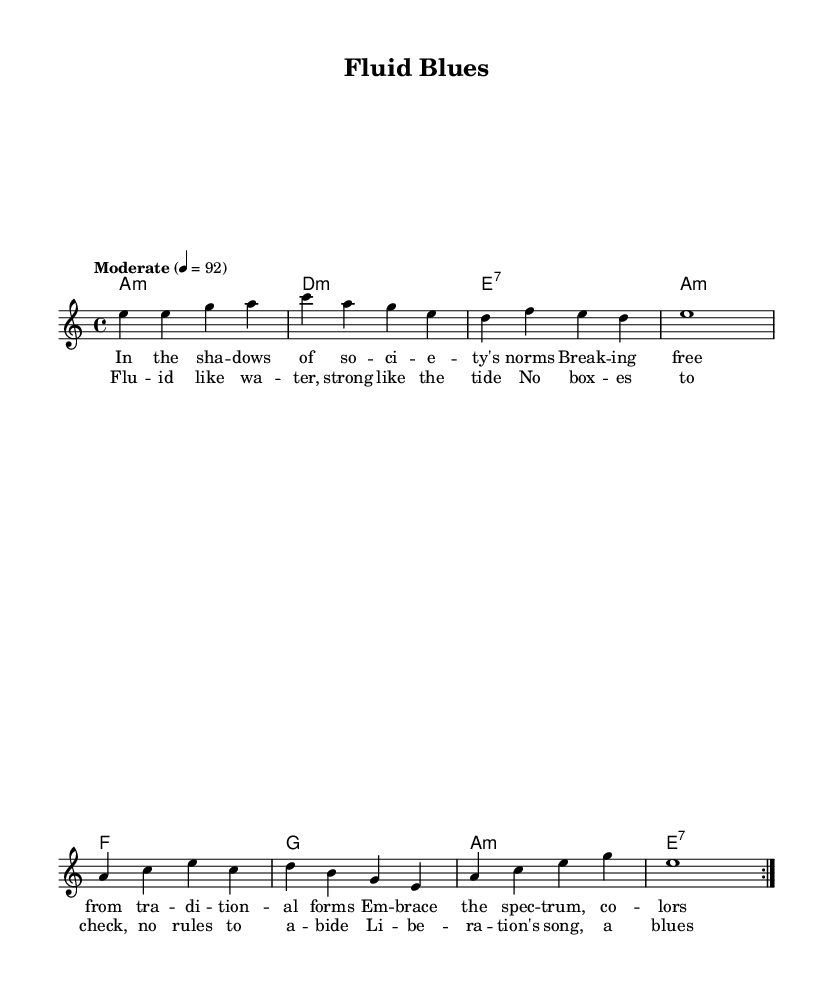What is the key signature of this music? The key signature is identified by the absence of sharps or flats in the title and throughout the piece, which indicates that it is in A minor.
Answer: A minor What is the time signature of this music? The time signature is shown at the beginning of the piece, indicated by the "4/4" notation, meaning there are four beats in each measure.
Answer: 4/4 What is the tempo marking for this piece? The tempo is indicated by the text "Moderate" followed by the metronome marking of 4 equals 92, which tells the performer how fast to play the music.
Answer: Moderate How many measures are in the repeated section of the melody? By analyzing the structure shown in the repeated section, there are two measures that consist of both the melody and the corresponding harmonies. Each section is marked with "volta 2" indicating the repetition.
Answer: Two measures What type of chords are used in the harmonies? By looking at the chord names, we can see that it features minor and seventh chords, which are characteristic of blues music. The chords are A minor, D minor, and E seventh among others.
Answer: Minor and seventh chords What is the main theme of the lyrics in this blues piece? The lyrics express themes of sexual liberation and gender fluidity, celebrating diversity in love and breaking free from societal norms, which is evident in the phrasing and words used throughout the verses and chorus.
Answer: Sexual liberation and gender fluidity What musical style is reflected through the lyrics and chords of this song? The combination of lyrics celebrating freedom and the use of traditionally blues chords indicates a modern interpretation of the blues genre, which often deals with themes of personal struggle and liberation.
Answer: Modern blues 